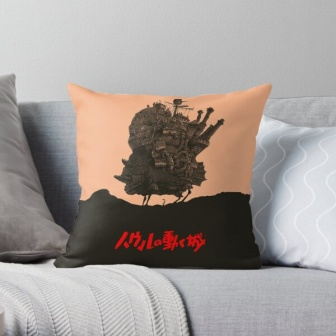What story could the castle on the pillow tell? The castle depicted on the pillow could tell a tale of a fantastical kingdom where every tower holds a secret, and each flag represents a faction or house within the realm. This castle might be perched atop a hill, surrounded by mystical forests and meandering rivers. It's a place where knights and sorcerers walk side by side, where dragons might soar overhead, and where the air is filled with the promise of adventure and magic. This enchanting castle evokes a sense of endless possibilities and invites those who see it to dream of the extraordinary stories that could unfold within its walls. 